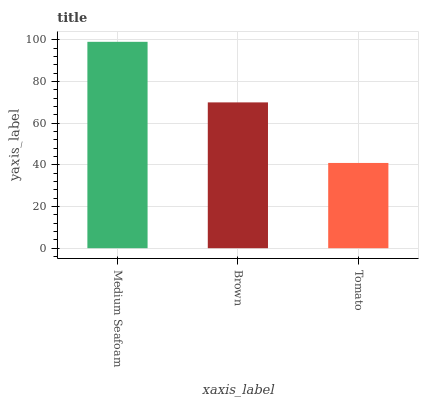Is Tomato the minimum?
Answer yes or no. Yes. Is Medium Seafoam the maximum?
Answer yes or no. Yes. Is Brown the minimum?
Answer yes or no. No. Is Brown the maximum?
Answer yes or no. No. Is Medium Seafoam greater than Brown?
Answer yes or no. Yes. Is Brown less than Medium Seafoam?
Answer yes or no. Yes. Is Brown greater than Medium Seafoam?
Answer yes or no. No. Is Medium Seafoam less than Brown?
Answer yes or no. No. Is Brown the high median?
Answer yes or no. Yes. Is Brown the low median?
Answer yes or no. Yes. Is Medium Seafoam the high median?
Answer yes or no. No. Is Medium Seafoam the low median?
Answer yes or no. No. 